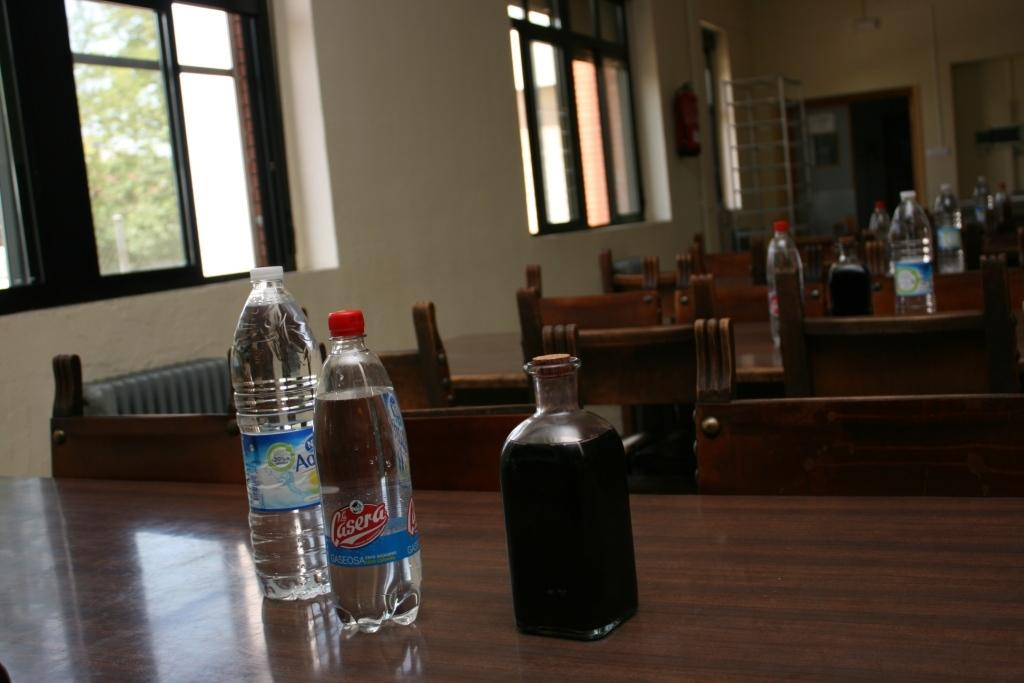<image>
Create a compact narrative representing the image presented. two bottles of water, one from nestle and the other from casera. 